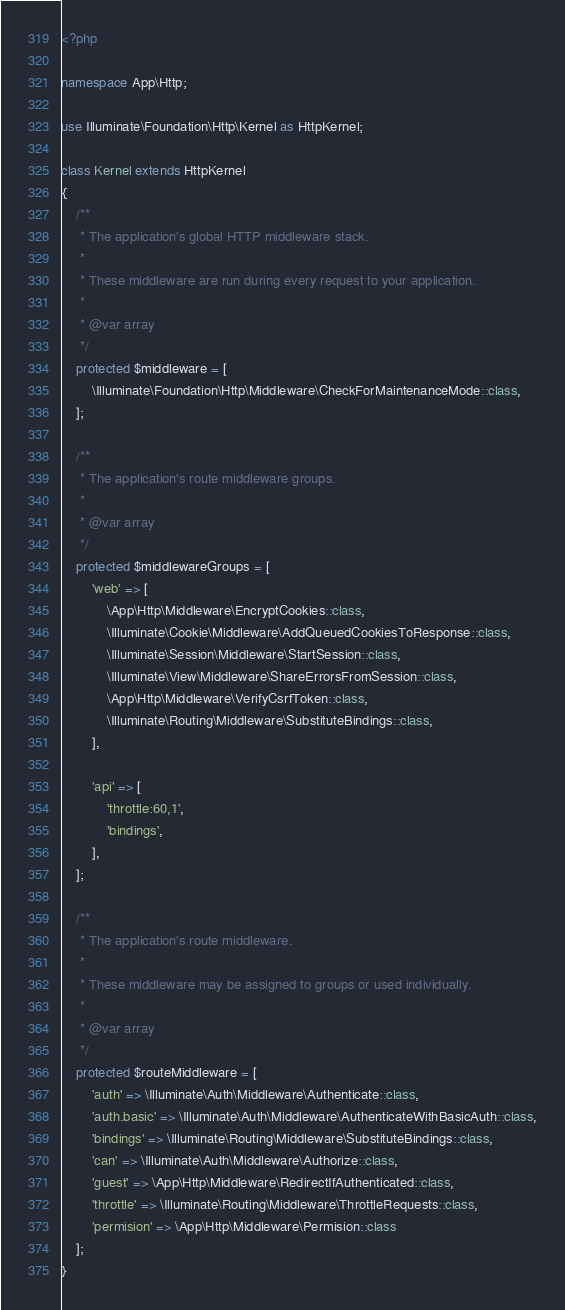Convert code to text. <code><loc_0><loc_0><loc_500><loc_500><_PHP_><?php

namespace App\Http;

use Illuminate\Foundation\Http\Kernel as HttpKernel;

class Kernel extends HttpKernel
{
    /**
     * The application's global HTTP middleware stack.
     *
     * These middleware are run during every request to your application.
     *
     * @var array
     */
    protected $middleware = [
        \Illuminate\Foundation\Http\Middleware\CheckForMaintenanceMode::class,
    ];

    /**
     * The application's route middleware groups.
     *
     * @var array
     */
    protected $middlewareGroups = [
        'web' => [
            \App\Http\Middleware\EncryptCookies::class,
            \Illuminate\Cookie\Middleware\AddQueuedCookiesToResponse::class,
            \Illuminate\Session\Middleware\StartSession::class,
            \Illuminate\View\Middleware\ShareErrorsFromSession::class,
            \App\Http\Middleware\VerifyCsrfToken::class,
            \Illuminate\Routing\Middleware\SubstituteBindings::class,
        ],

        'api' => [
            'throttle:60,1',
            'bindings',
        ],
    ];

    /**
     * The application's route middleware.
     *
     * These middleware may be assigned to groups or used individually.
     *
     * @var array
     */
    protected $routeMiddleware = [
        'auth' => \Illuminate\Auth\Middleware\Authenticate::class,
        'auth.basic' => \Illuminate\Auth\Middleware\AuthenticateWithBasicAuth::class,
        'bindings' => \Illuminate\Routing\Middleware\SubstituteBindings::class,
        'can' => \Illuminate\Auth\Middleware\Authorize::class,
        'guest' => \App\Http\Middleware\RedirectIfAuthenticated::class,
        'throttle' => \Illuminate\Routing\Middleware\ThrottleRequests::class,
        'permision' => \App\Http\Middleware\Permision::class
    ];
}
</code> 